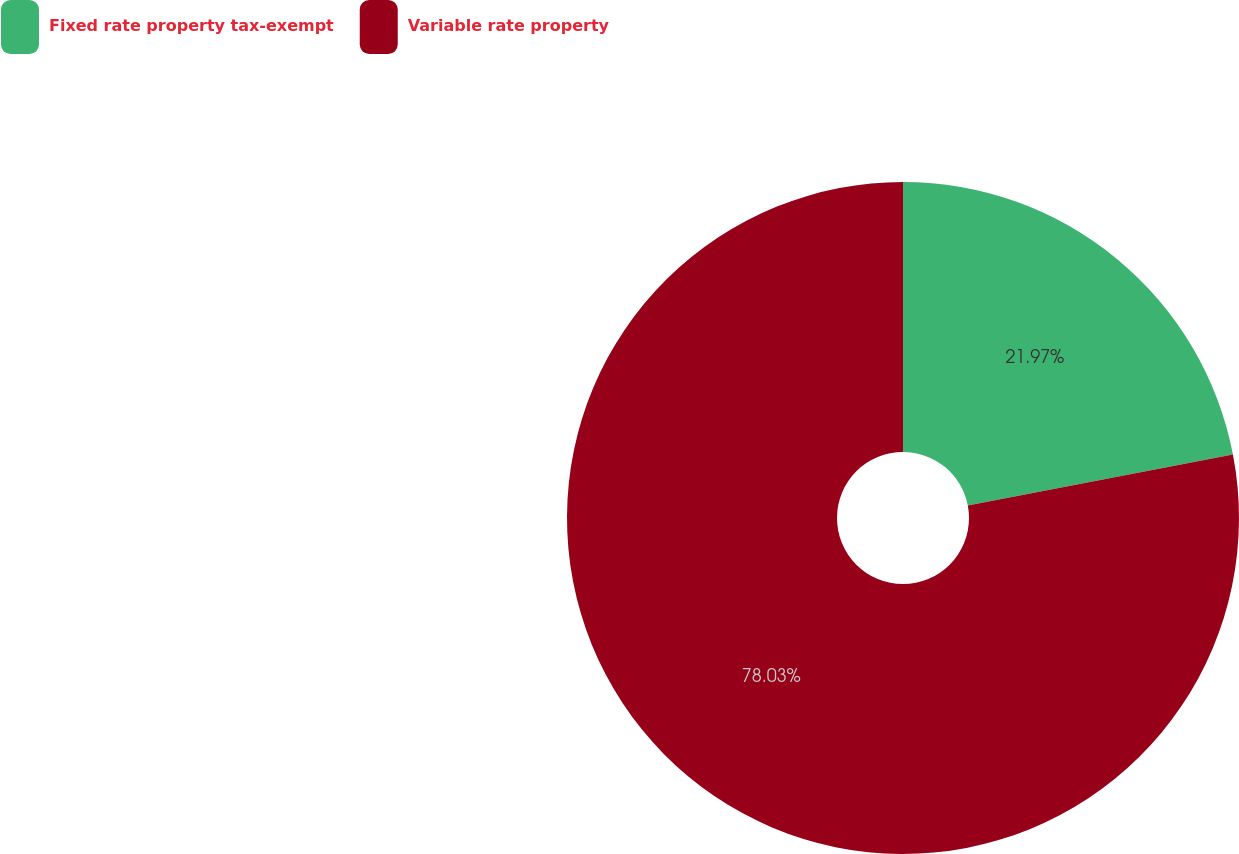Convert chart. <chart><loc_0><loc_0><loc_500><loc_500><pie_chart><fcel>Fixed rate property tax-exempt<fcel>Variable rate property<nl><fcel>21.97%<fcel>78.03%<nl></chart> 